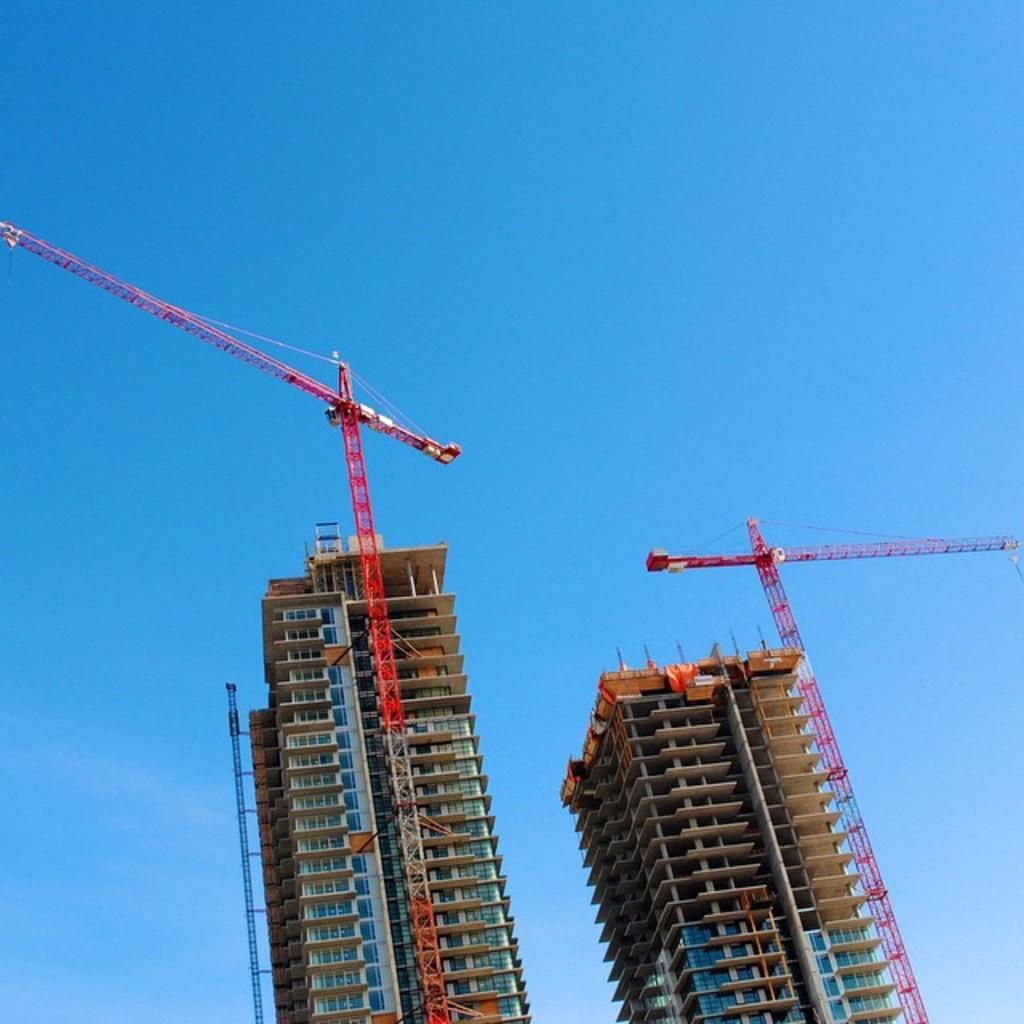How would you summarize this image in a sentence or two? In the image we can see two crane tower and constructions. Behind them there is sky. 